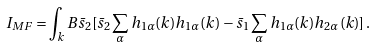<formula> <loc_0><loc_0><loc_500><loc_500>I _ { M F } = \int _ { k } B \bar { s } _ { 2 } [ \bar { s } _ { 2 } \sum _ { \alpha } h _ { 1 \alpha } ( k ) h _ { 1 \alpha } ( k ) - \bar { s } _ { 1 } \sum _ { \alpha } h _ { 1 \alpha } ( k ) h _ { 2 \alpha } ( k ) ] \, .</formula> 